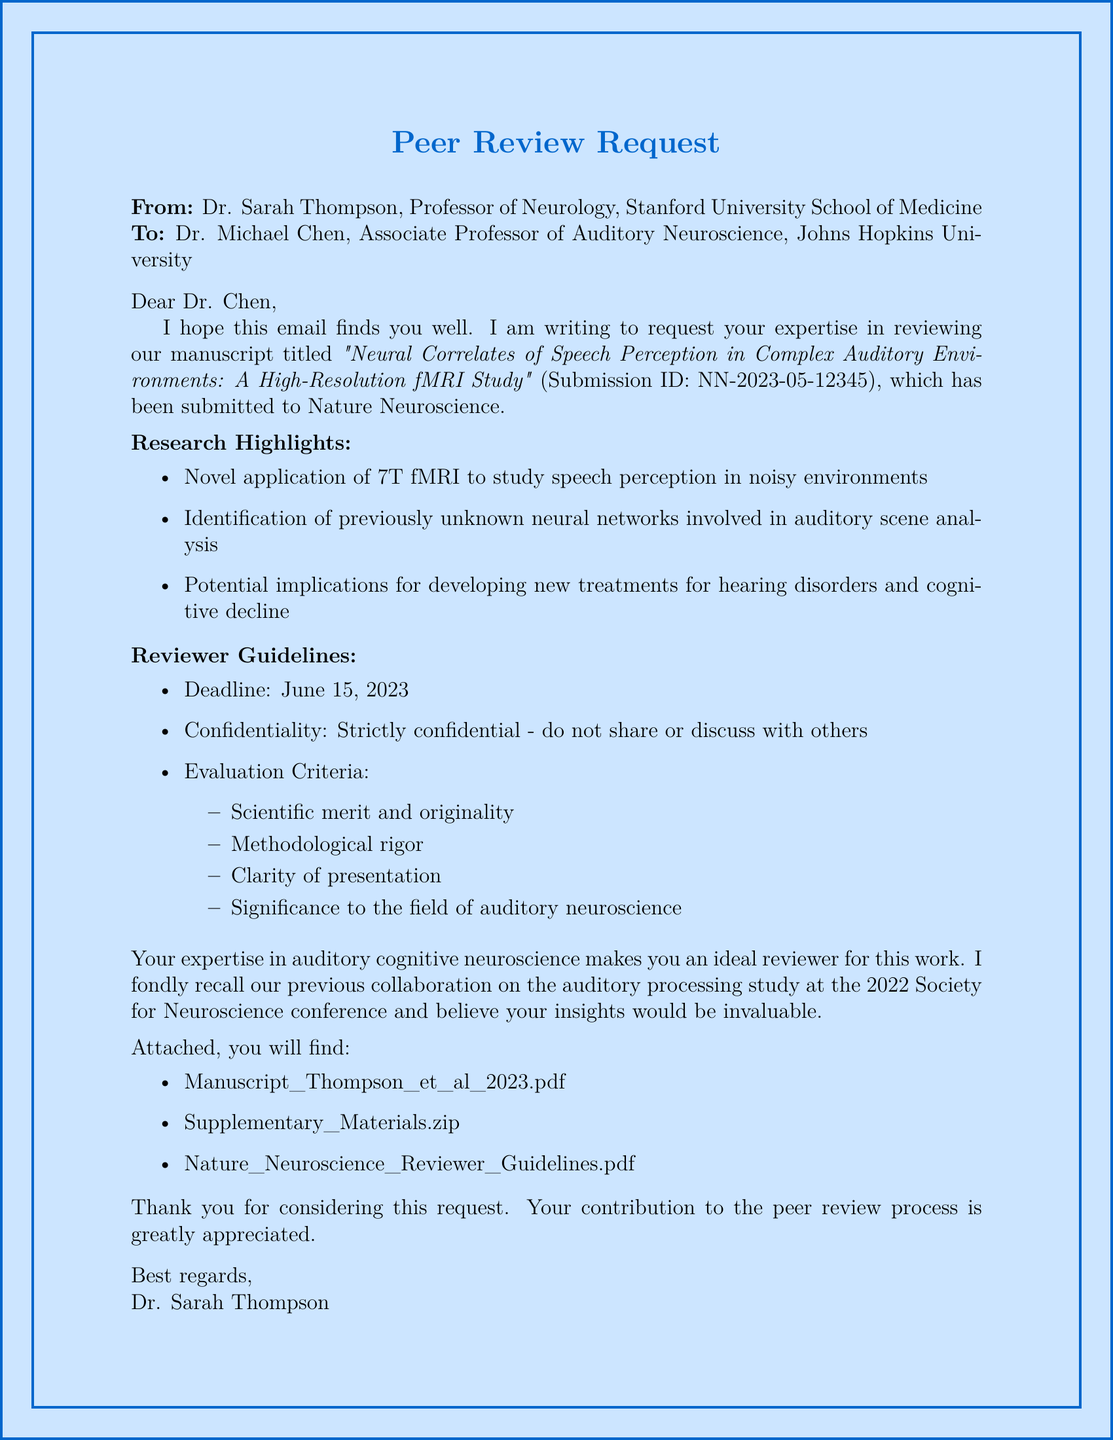What is the title of the paper? The title of the paper is specifically mentioned in the document.
Answer: Neural Correlates of Speech Perception in Complex Auditory Environments: A High-Resolution fMRI Study Who is the sender of the email? The email clearly lists the sender's name and title at the beginning.
Answer: Dr. Sarah Thompson What is the deadline for the review? The deadline for the review is specified in the reviewer guidelines section of the document.
Answer: June 15, 2023 Which journal is the paper submitted to? The journal name is indicated alongside the paper details.
Answer: Nature Neuroscience What are the key research highlights mentioned? The document lists three main research highlights under a specific section.
Answer: Novel application of 7T fMRI to study speech perception in noisy environments What is the submission ID? The submission ID is provided with the paper details for reference.
Answer: NN-2023-05-12345 What previous event is mentioned in relation to the collaboration history? The collaboration history refers to a specific event where the two correspondents previously worked together.
Answer: 2022 Society for Neuroscience conference What are the evaluation criteria for the manuscript? The evaluation criteria are outlined as a list and indicate what aspects reviewers should focus on.
Answer: Scientific merit and originality What does the confidentiality guideline state? The confidentiality guideline is summarized clearly in the reviewer guidelines.
Answer: Strictly confidential - do not share or discuss with others 